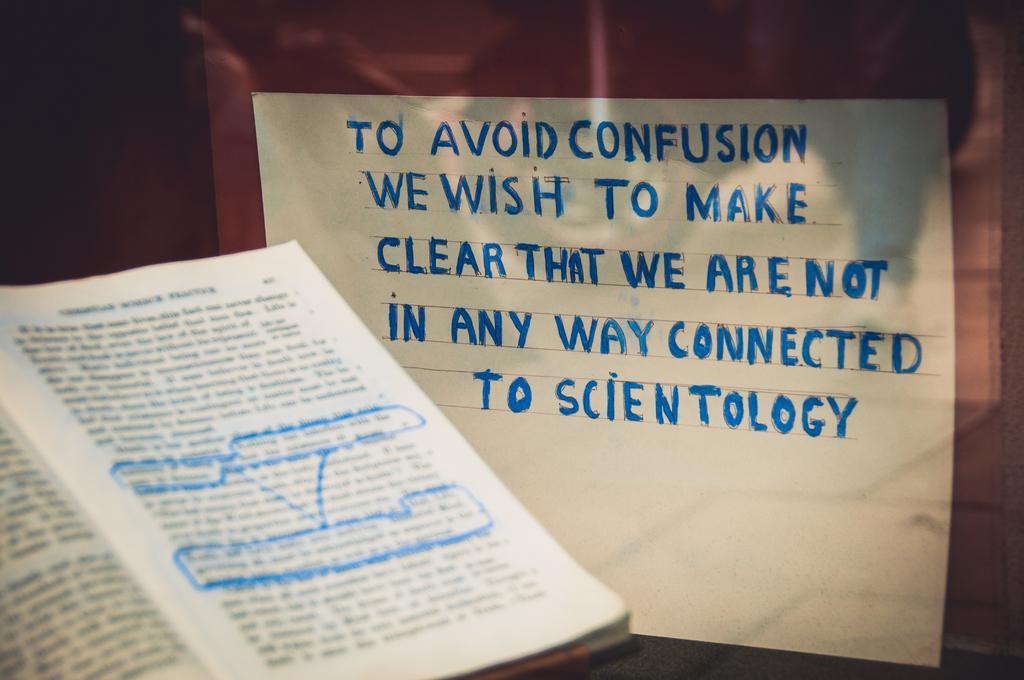Could you give a brief overview of what you see in this image? In the picture I can see an opened book on the left side. There is a white sheet on the right side with text on it. 